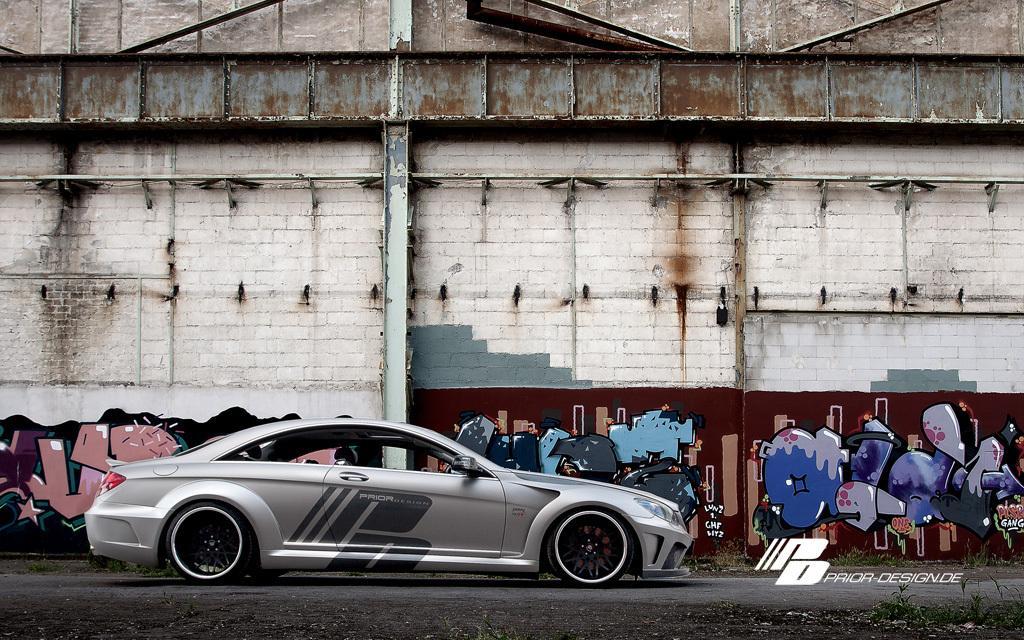Could you give a brief overview of what you see in this image? In the center of the image there is a car on the road. In the background of the image there is a building. There is a painting on the wall. At the bottom of the image there is some text. 